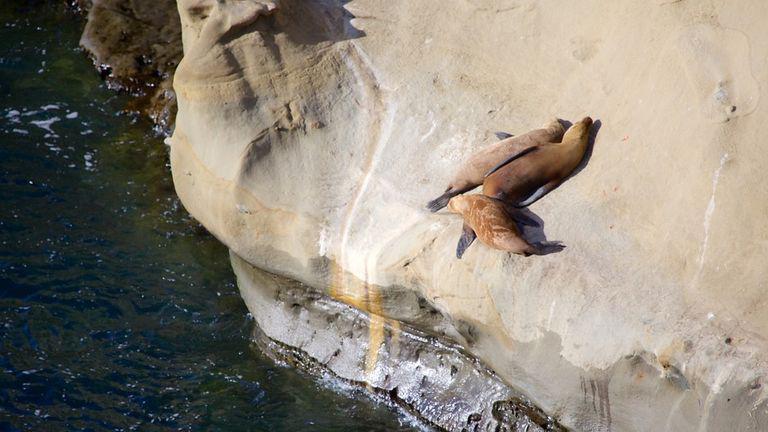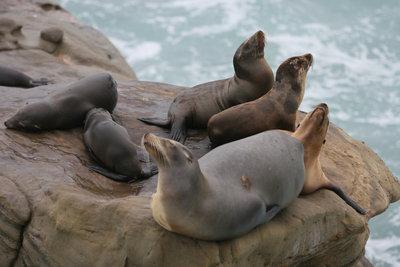The first image is the image on the left, the second image is the image on the right. Given the left and right images, does the statement "No image contains more than seven seals, and at least one image shows seals on a rock above water." hold true? Answer yes or no. Yes. 